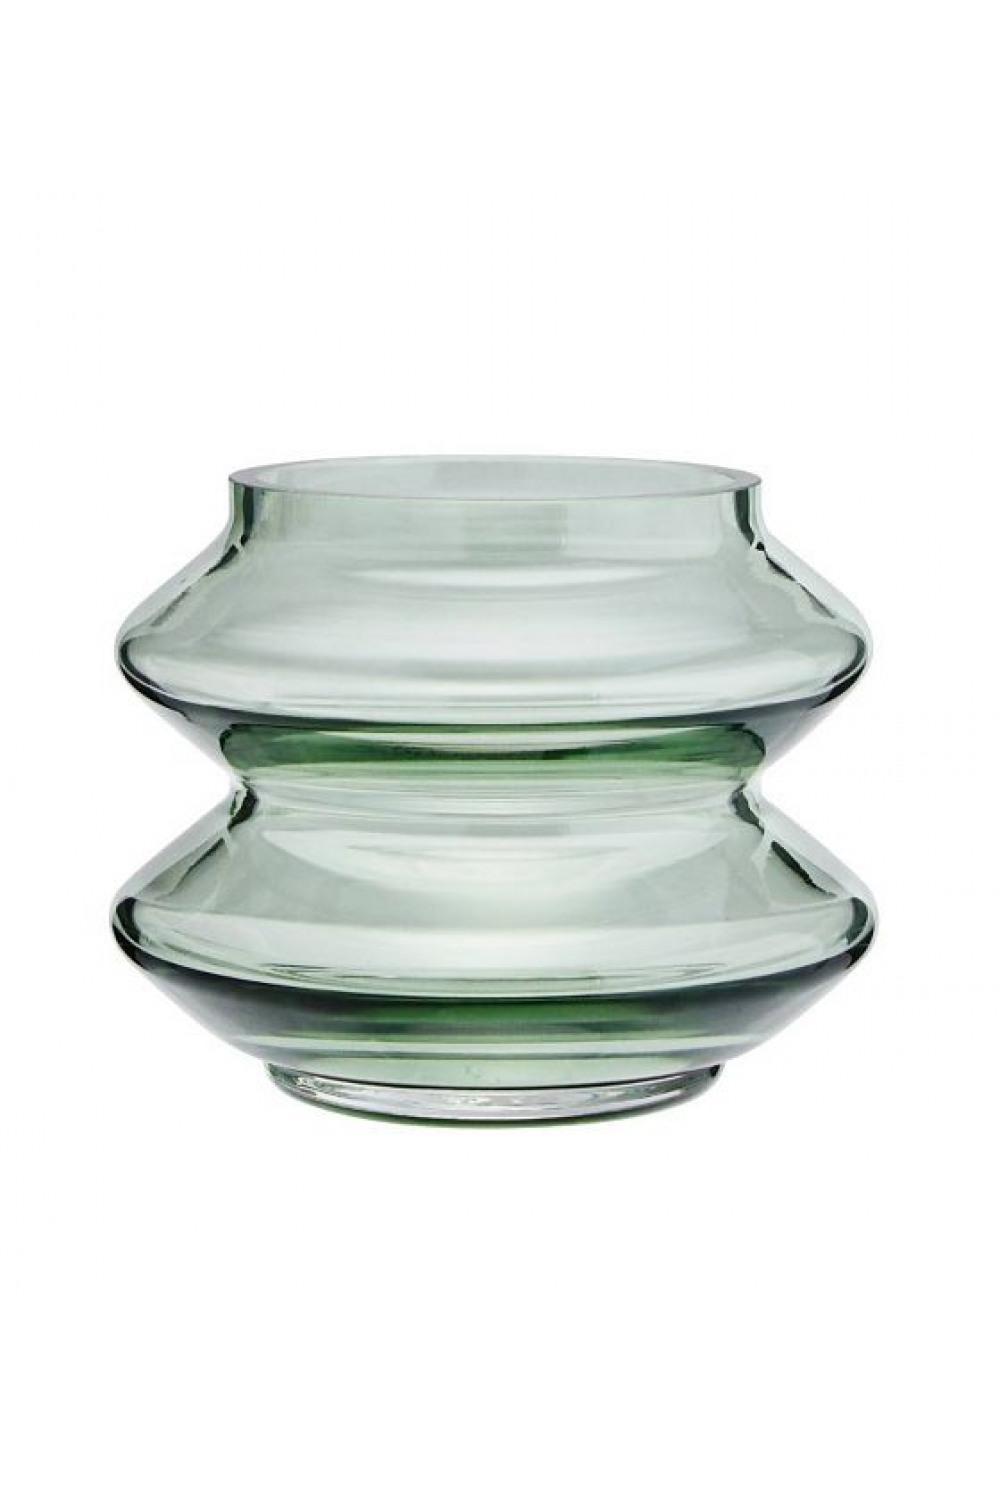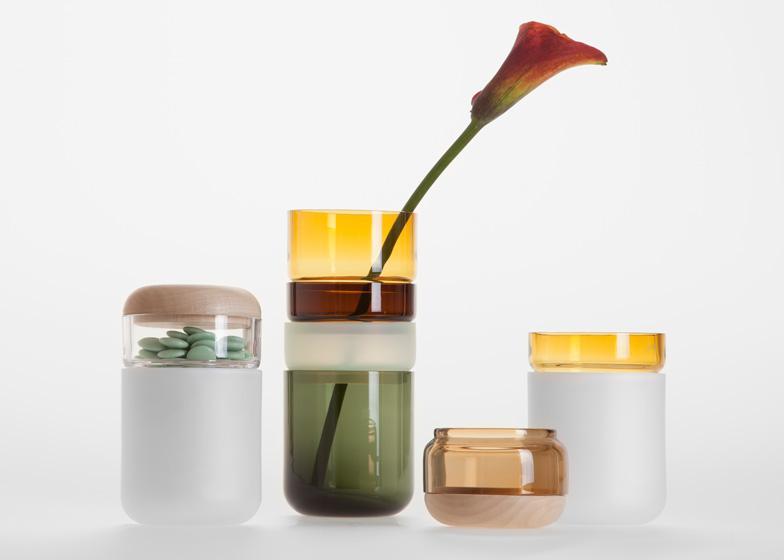The first image is the image on the left, the second image is the image on the right. Examine the images to the left and right. Is the description "The number of jars in one image without lids is the same number in the other image with lids." accurate? Answer yes or no. No. The first image is the image on the left, the second image is the image on the right. Assess this claim about the two images: "An image shows a jar with a flower in it.". Correct or not? Answer yes or no. Yes. 